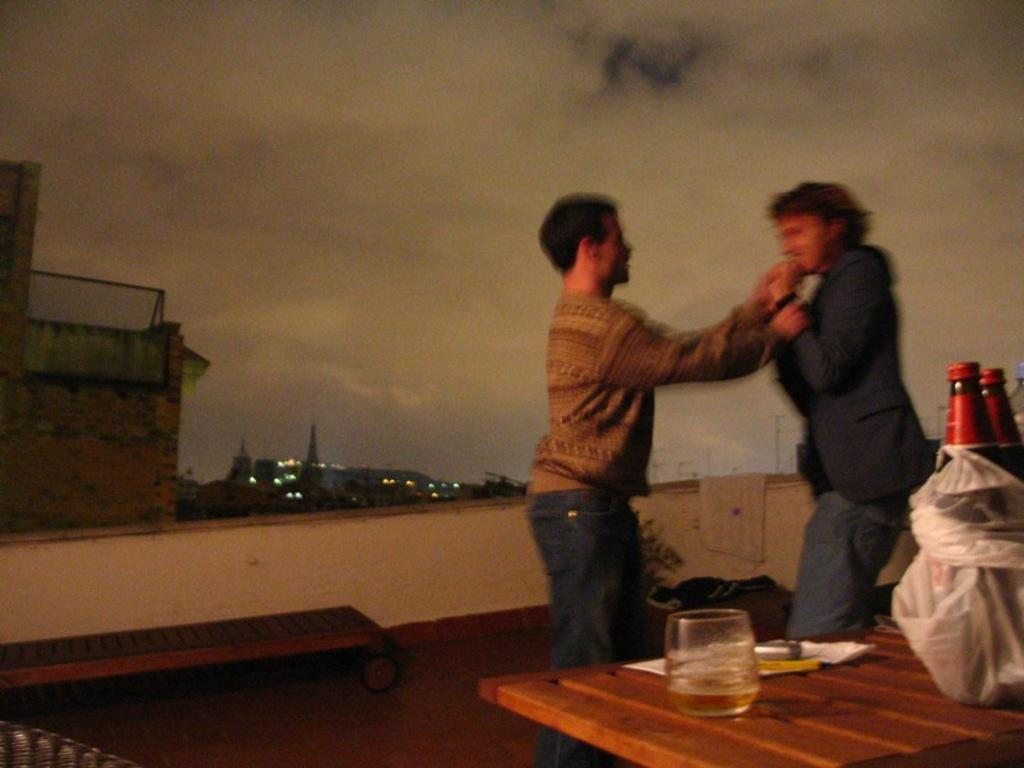How many people are in the image? There are two persons in the image. What are the two persons doing? The two persons are holding each other. What is located beside the two persons? There is a table beside the two persons. What can be seen on the table? There is a wine bottle and a glass of wine on the table. What is visible in the background of the image? There are buildings visible in the image. Where is the chair located in the image? There is no chair present in the image. Can you see any docks in the image? There is no dock present in the image. 